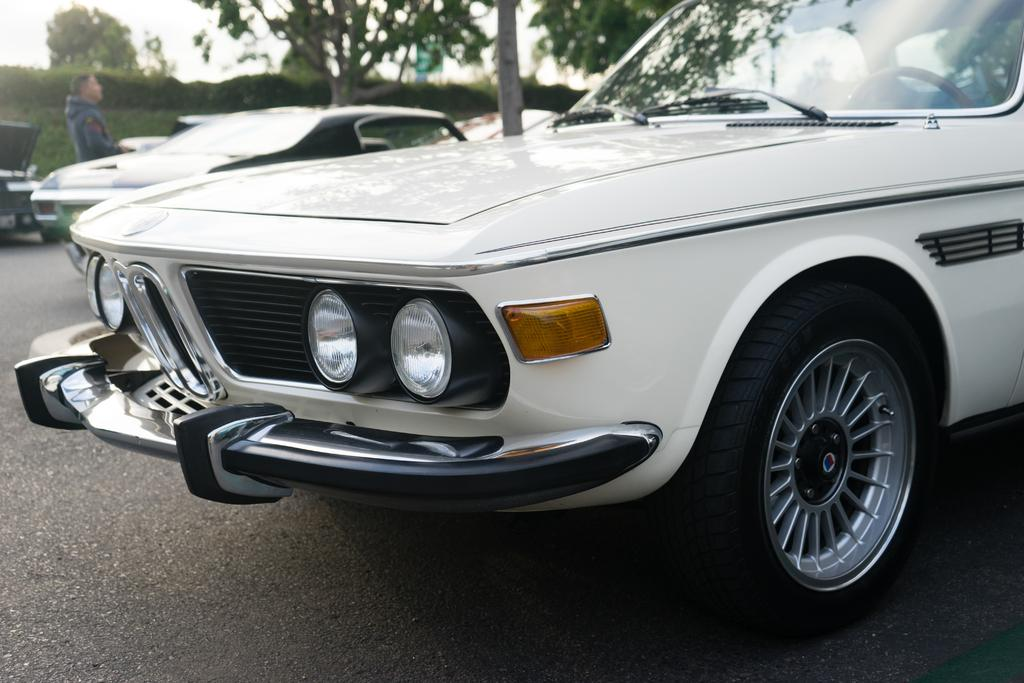What can be seen on the road in the image? There are vehicles on the road in the image. Can you describe the person in the image? There is a person in the image. What type of natural elements are visible in the background of the image? There are plants and trees in the background of the image. Where is the ornament located in the image? There is no ornament present in the image. Can you describe the lake in the image? There is no lake present in the image. 